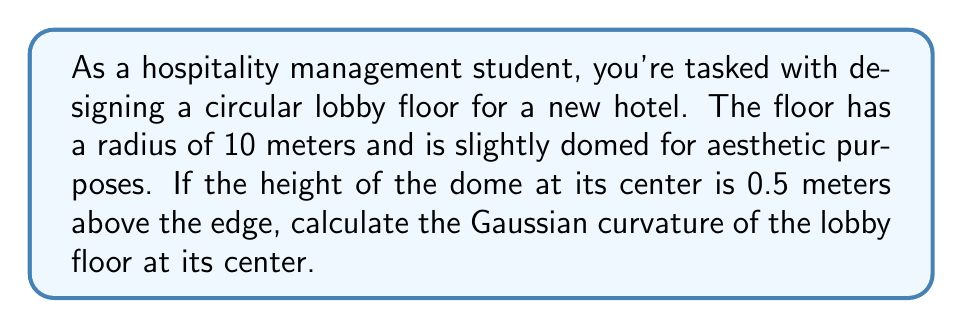Provide a solution to this math problem. To solve this problem, we'll follow these steps:

1) First, we need to model the surface of the lobby floor. Given the circular shape and domed nature, we can represent it as a spherical cap.

2) The formula for Gaussian curvature (K) of a sphere is:

   $$K = \frac{1}{R^2}$$

   where R is the radius of the sphere.

3) We need to find R. We can do this using the equation of a circle:

   $$r^2 + (R-h)^2 = R^2$$

   where r is the radius of the base (10 m), h is the height of the dome (0.5 m), and R is the radius of the sphere we're looking for.

4) Substituting the known values:

   $$10^2 + (R-0.5)^2 = R^2$$

5) Expanding:

   $$100 + R^2 - R + 0.25 = R^2$$

6) Simplifying:

   $$100.25 = R$$

7) Now that we have R, we can calculate the Gaussian curvature:

   $$K = \frac{1}{R^2} = \frac{1}{(100.25)^2} \approx 0.0000995 \text{ m}^{-2}$$
Answer: $0.0000995 \text{ m}^{-2}$ 